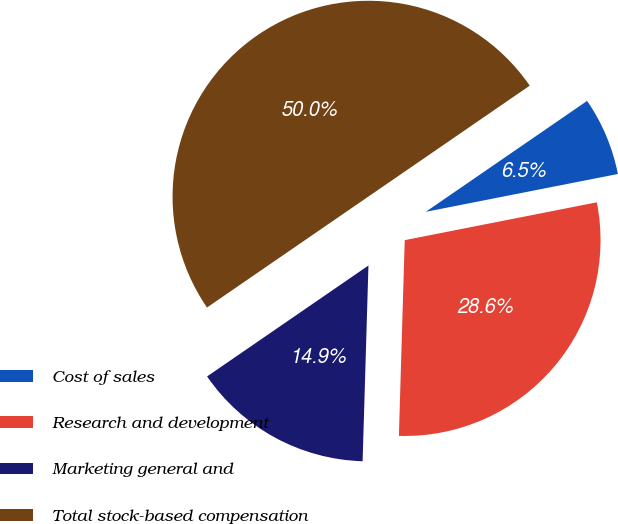<chart> <loc_0><loc_0><loc_500><loc_500><pie_chart><fcel>Cost of sales<fcel>Research and development<fcel>Marketing general and<fcel>Total stock-based compensation<nl><fcel>6.49%<fcel>28.57%<fcel>14.94%<fcel>50.0%<nl></chart> 